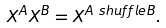<formula> <loc_0><loc_0><loc_500><loc_500>X ^ { A } X ^ { B } & = X ^ { A \ s h u f f l e B } .</formula> 